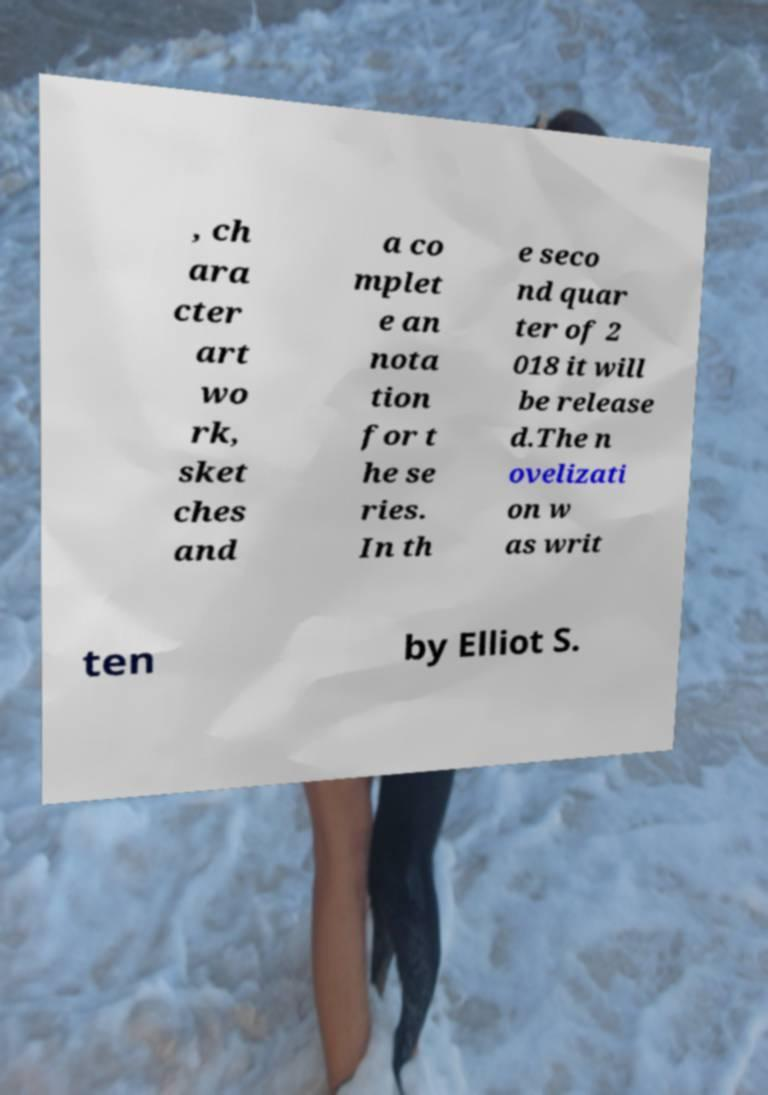Could you assist in decoding the text presented in this image and type it out clearly? , ch ara cter art wo rk, sket ches and a co mplet e an nota tion for t he se ries. In th e seco nd quar ter of 2 018 it will be release d.The n ovelizati on w as writ ten by Elliot S. 